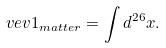<formula> <loc_0><loc_0><loc_500><loc_500>\ v e v { 1 } _ { m a t t e r } = \int d ^ { 2 6 } x .</formula> 